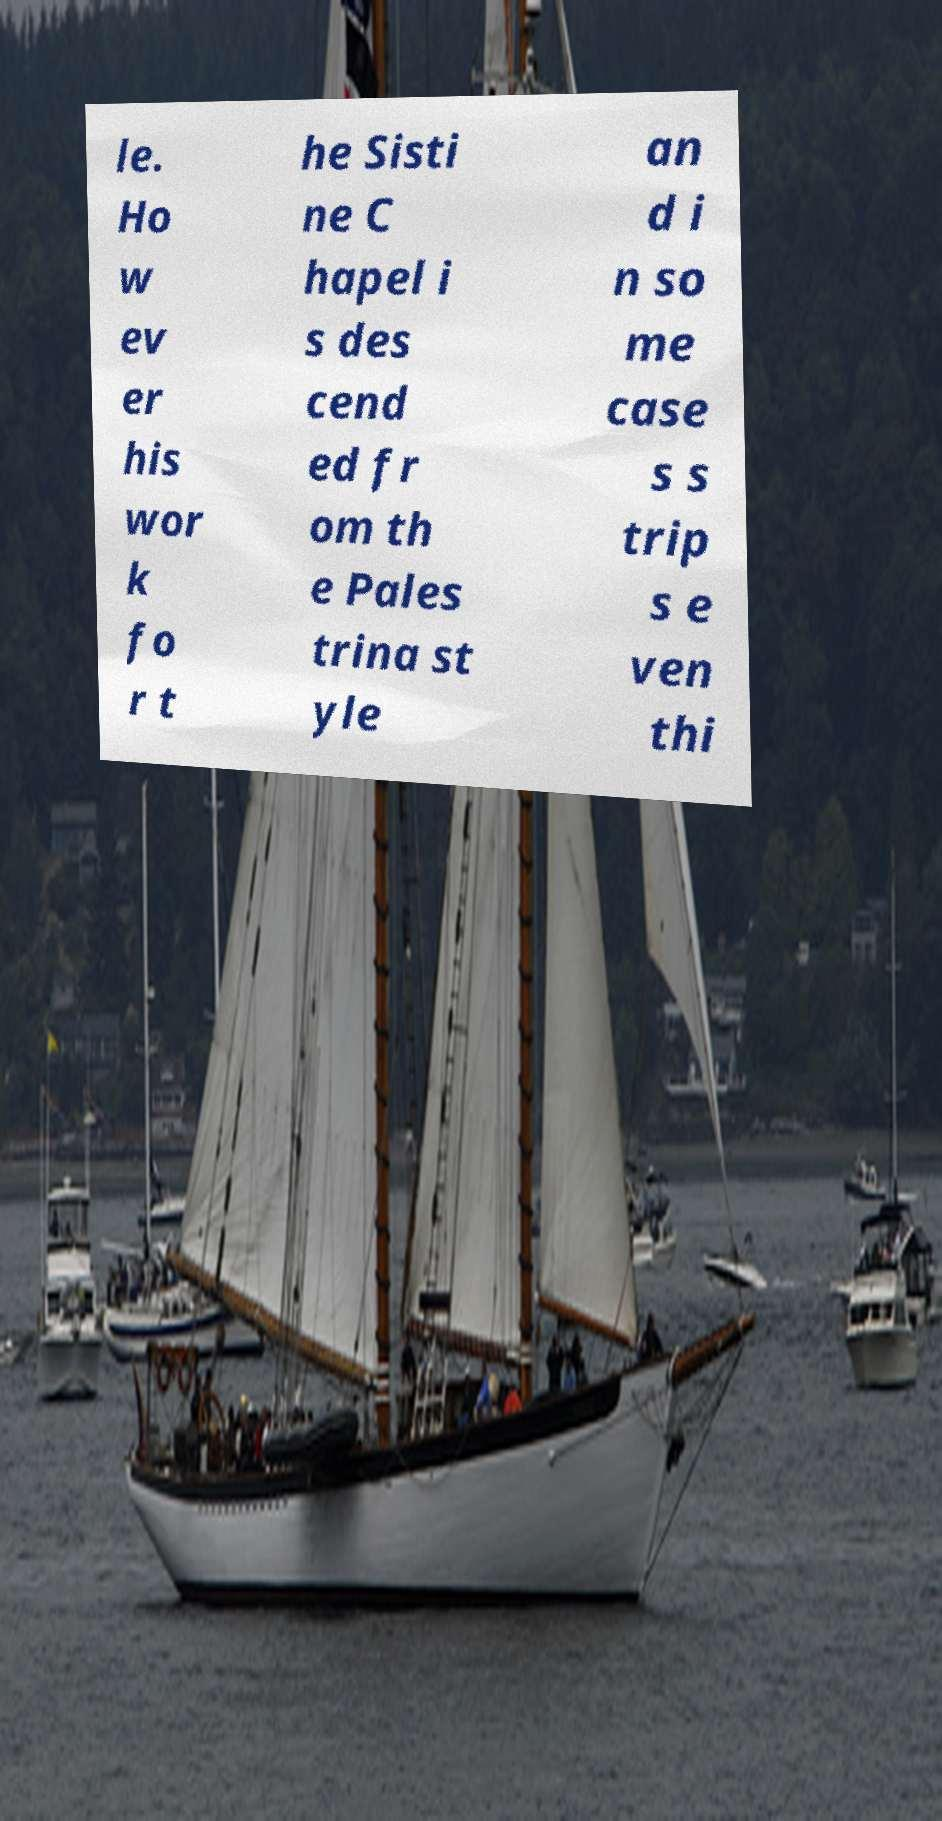What messages or text are displayed in this image? I need them in a readable, typed format. le. Ho w ev er his wor k fo r t he Sisti ne C hapel i s des cend ed fr om th e Pales trina st yle an d i n so me case s s trip s e ven thi 